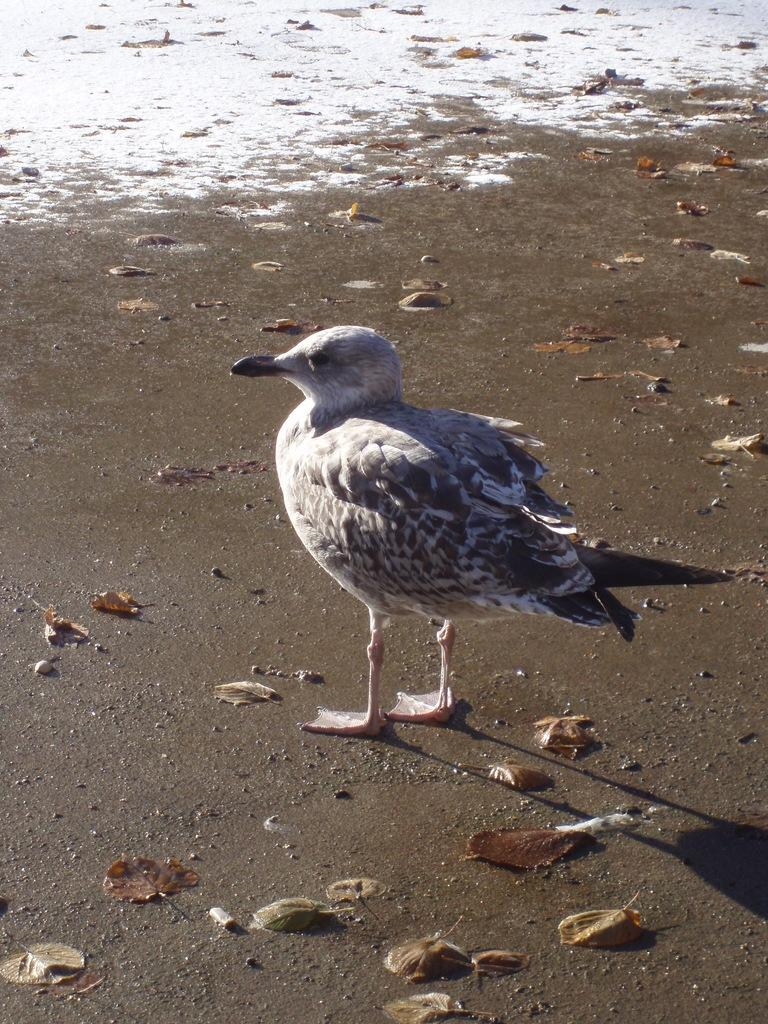What type of animal can be seen in the image? There is a bird in the image. Where is the bird located in the image? The bird is standing on the ground. What else can be seen on the ground in the image? There are dried leaves on the ground. What is visible at the top of the image? There is water visible at the top of the image. How many baseballs can be seen in the image? There are no baseballs present in the image. Is the bird's father visible in the image? There is no reference to a bird's father in the image, so it is not possible to answer that question. 